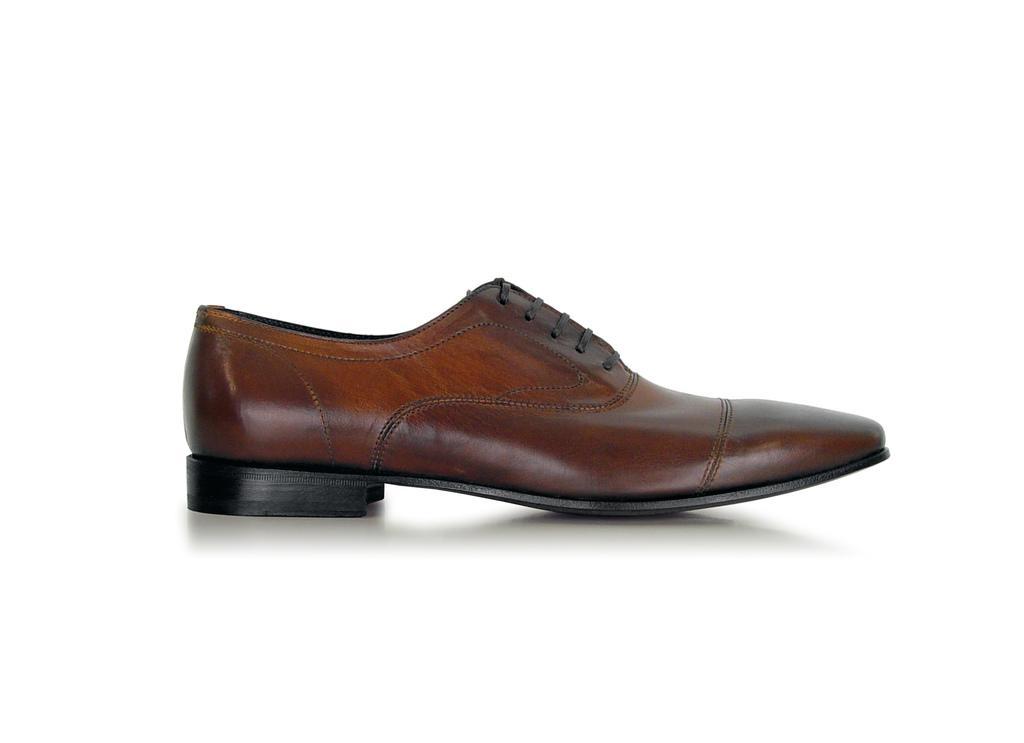Can you describe this image briefly? There is a brown color shoe in the white background. 